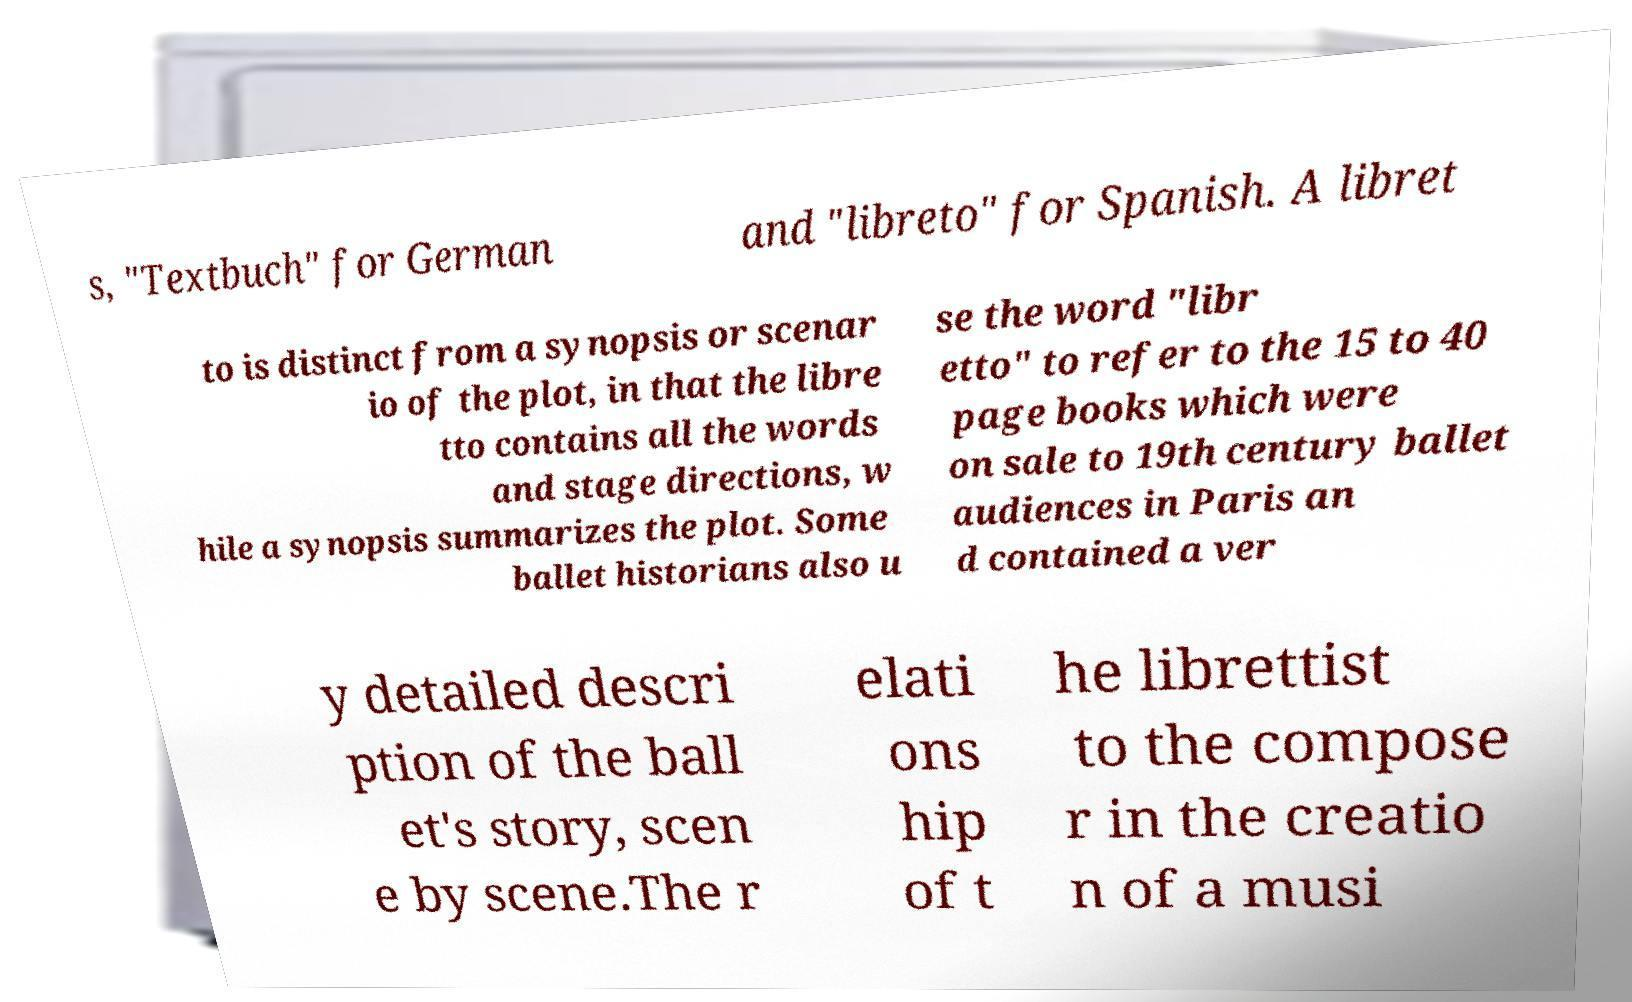Please read and relay the text visible in this image. What does it say? s, "Textbuch" for German and "libreto" for Spanish. A libret to is distinct from a synopsis or scenar io of the plot, in that the libre tto contains all the words and stage directions, w hile a synopsis summarizes the plot. Some ballet historians also u se the word "libr etto" to refer to the 15 to 40 page books which were on sale to 19th century ballet audiences in Paris an d contained a ver y detailed descri ption of the ball et's story, scen e by scene.The r elati ons hip of t he librettist to the compose r in the creatio n of a musi 